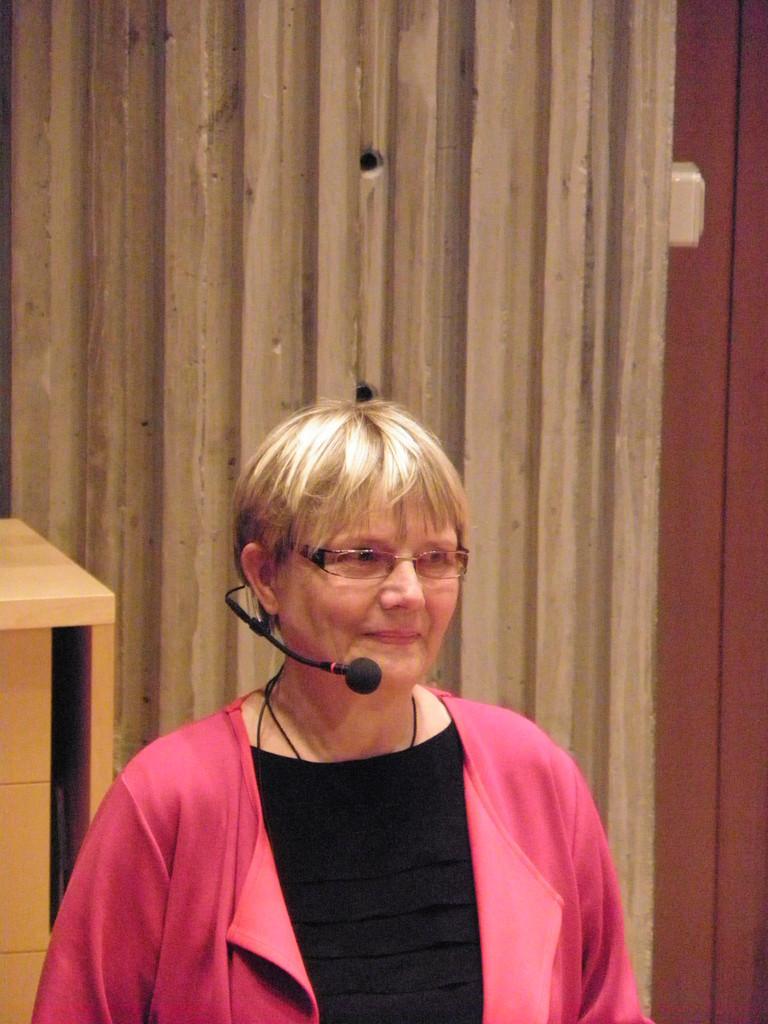Describe this image in one or two sentences. In the image there is a blond haired old woman in peach jacket with mic standing in the front and behind her there is wall and a table on the left side. 